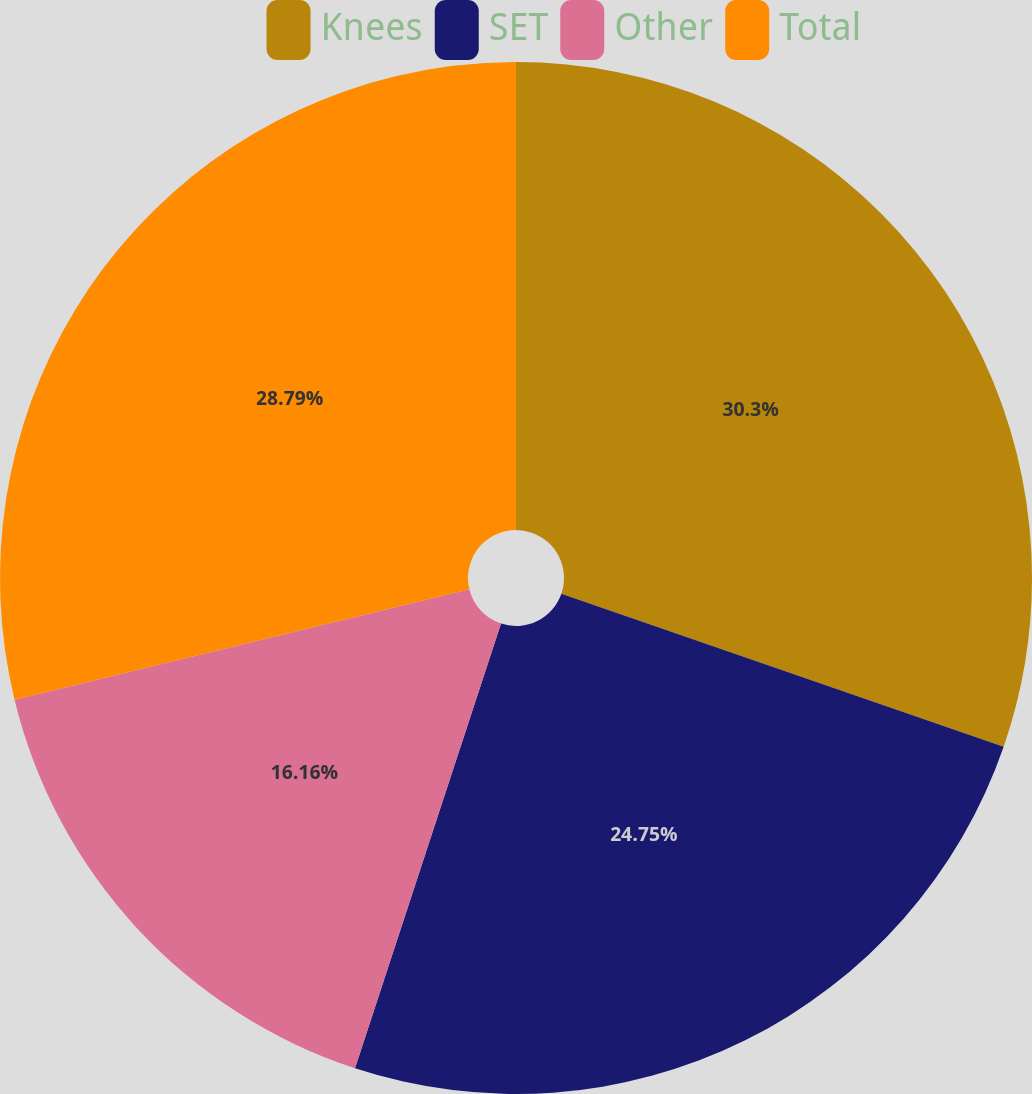Convert chart to OTSL. <chart><loc_0><loc_0><loc_500><loc_500><pie_chart><fcel>Knees<fcel>SET<fcel>Other<fcel>Total<nl><fcel>30.3%<fcel>24.75%<fcel>16.16%<fcel>28.79%<nl></chart> 